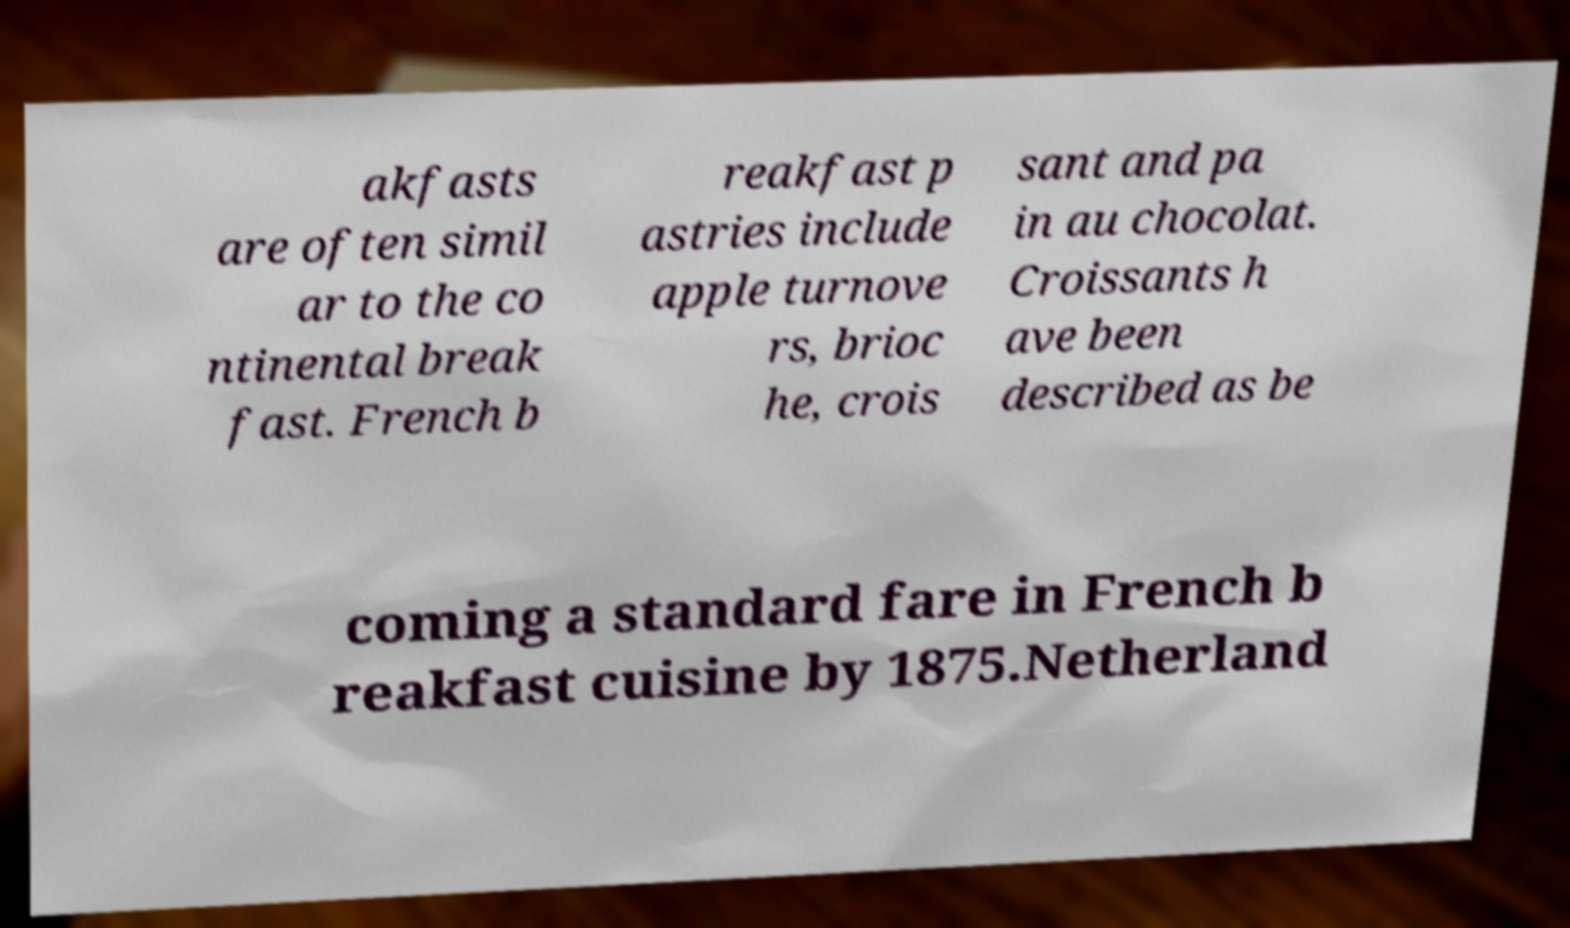Please identify and transcribe the text found in this image. akfasts are often simil ar to the co ntinental break fast. French b reakfast p astries include apple turnove rs, brioc he, crois sant and pa in au chocolat. Croissants h ave been described as be coming a standard fare in French b reakfast cuisine by 1875.Netherland 